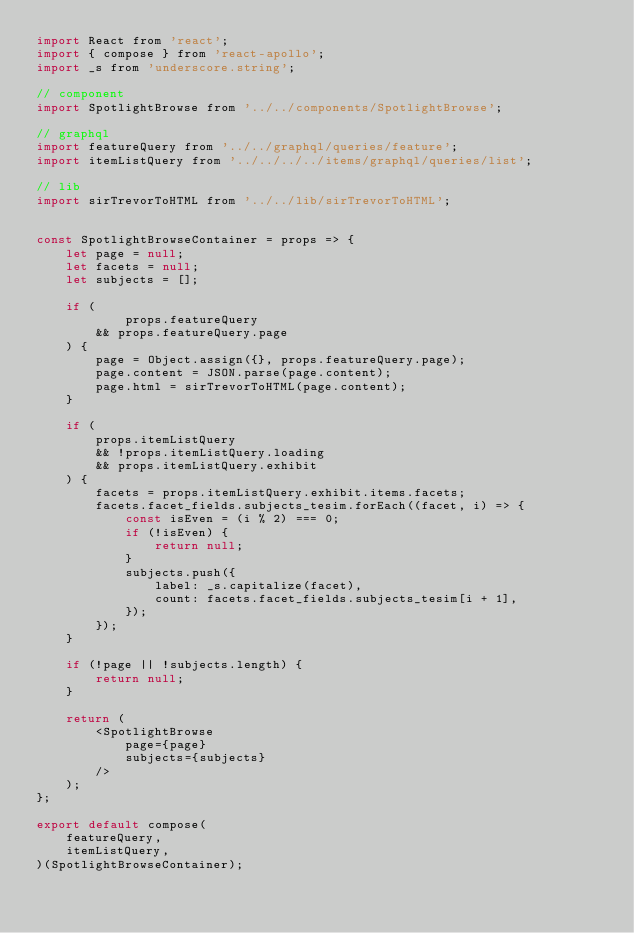Convert code to text. <code><loc_0><loc_0><loc_500><loc_500><_JavaScript_>import React from 'react';
import { compose } from 'react-apollo';
import _s from 'underscore.string';

// component
import SpotlightBrowse from '../../components/SpotlightBrowse';

// graphql
import featureQuery from '../../graphql/queries/feature';
import itemListQuery from '../../../../items/graphql/queries/list';

// lib
import sirTrevorToHTML from '../../lib/sirTrevorToHTML';


const SpotlightBrowseContainer = props => {
	let page = null;
	let facets = null;
	let subjects = [];

	if (
			props.featureQuery
		&& props.featureQuery.page
	) {
		page = Object.assign({}, props.featureQuery.page);
		page.content = JSON.parse(page.content);
		page.html = sirTrevorToHTML(page.content);
	}

	if (
		props.itemListQuery
		&& !props.itemListQuery.loading
		&& props.itemListQuery.exhibit
	) {
		facets = props.itemListQuery.exhibit.items.facets;
		facets.facet_fields.subjects_tesim.forEach((facet, i) => {
			const isEven = (i % 2) === 0;
			if (!isEven) {
				return null;
			}
			subjects.push({
				label: _s.capitalize(facet),
				count: facets.facet_fields.subjects_tesim[i + 1],
			});
		});
	}

	if (!page || !subjects.length) {
		return null;
	}

	return (
		<SpotlightBrowse
			page={page}
			subjects={subjects}
		/>
	);
};

export default compose(
	featureQuery,
	itemListQuery,
)(SpotlightBrowseContainer);
</code> 